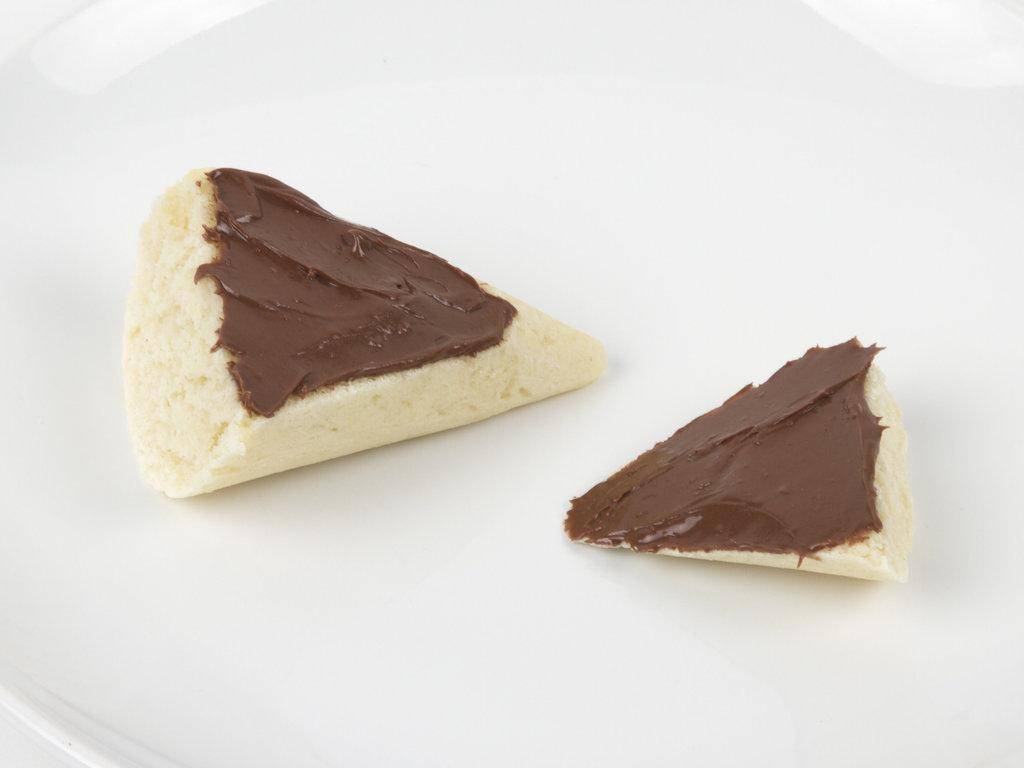What is the color of the plate in the image? The plate in the image is white. Where is the plate located in the image? The plate is in the center of the image. What type of food is on the plate? There are chocolate cakes on the plate. What color is the yak in the image? There is no yak present in the image. What type of sheet is covering the chocolate cakes on the plate? There is no sheet covering the chocolate cakes on the plate in the image. 